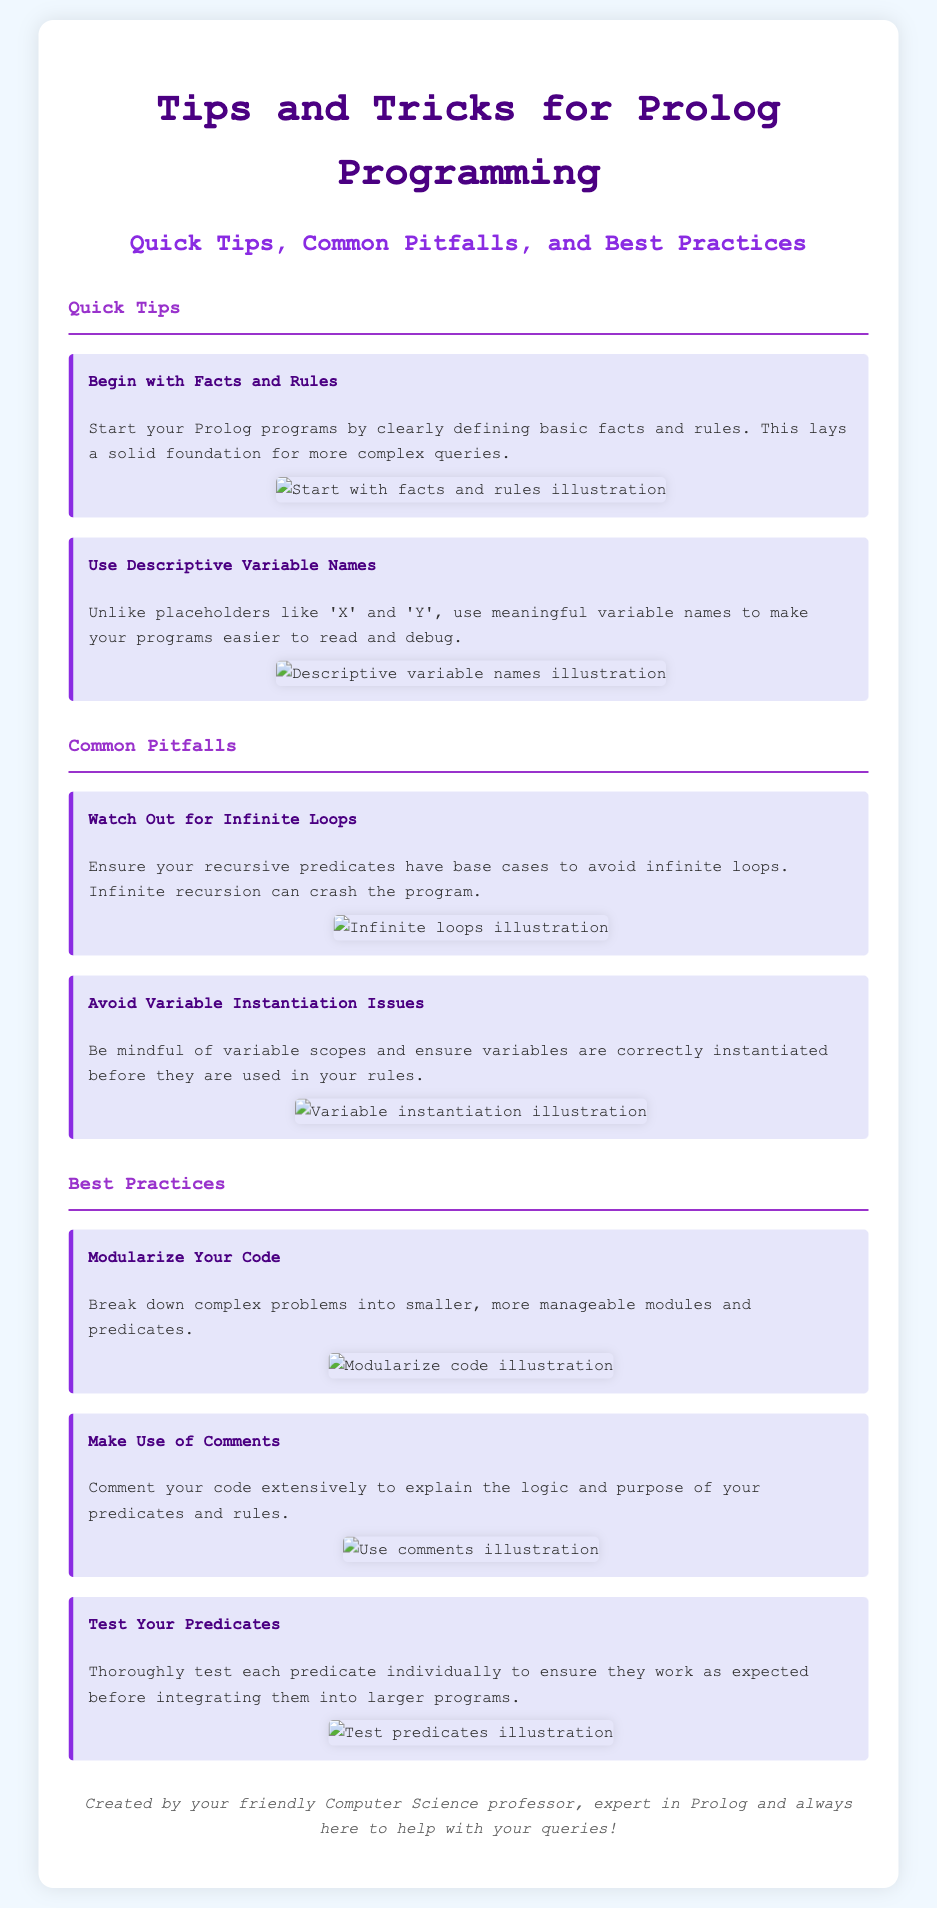What is the title of the flyer? The title of the flyer is mentioned prominently at the top of the document, indicating the main topic.
Answer: Tips and Tricks for Prolog Programming What are the first two quick tips listed? The document includes a section for quick tips, which provides some initial suggestions for programming in Prolog.
Answer: Begin with Facts and Rules, Use Descriptive Variable Names What is one common pitfall mentioned? The document discusses several common pitfalls in Prolog programming, highlighting issues that programmers should be cautious of.
Answer: Watch Out for Infinite Loops What should be ensured to avoid infinite loops? The text under the common pitfalls section stresses a specific condition that needs to be met to prevent issues in programming.
Answer: Base cases How should one write variable names according to the flyer? The flyer advises a specific approach towards naming in Prolog, aiming to improve readability and maintainability of code.
Answer: Descriptive Variable Names What is a recommended best practice regarding code organization? The best practices section mentions an effective technique for managing complex Prolog code, which is significant for programming efficiency.
Answer: Modularize Your Code What should you do extensively to clarify the code logic? The flyer provides advice about documentation within the code, indicating a practice that aids understanding of the logic used within Prolog programs.
Answer: Make Use of Comments How many best practices are highlighted in the document? The document clearly lists out various best practices within its section, indicating the amount of advice given.
Answer: Three Who created this flyer? The footer includes credit for the creation of the flyer, reflecting on the author's relationship with the subject matter.
Answer: Your friendly Computer Science professor 